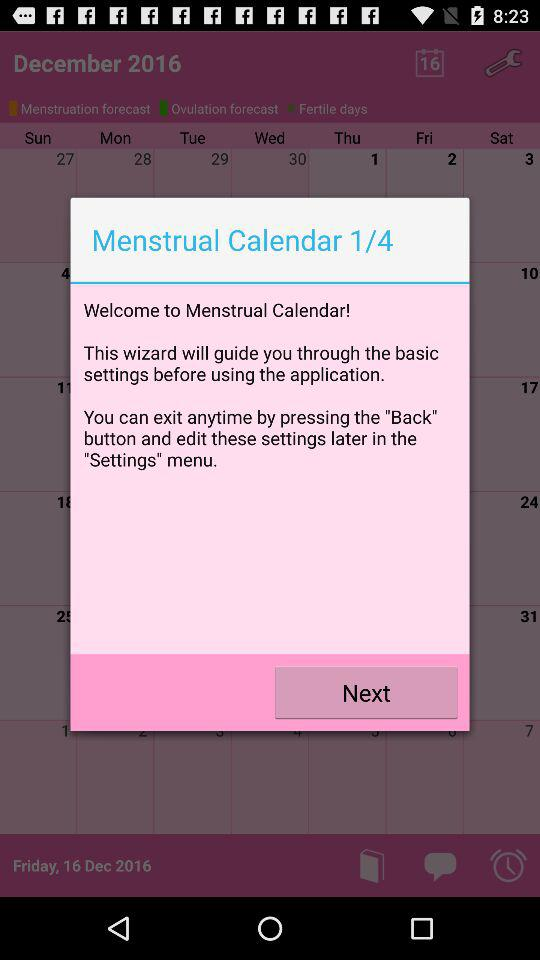How many text elements are on the screen?
Answer the question using a single word or phrase. 4 